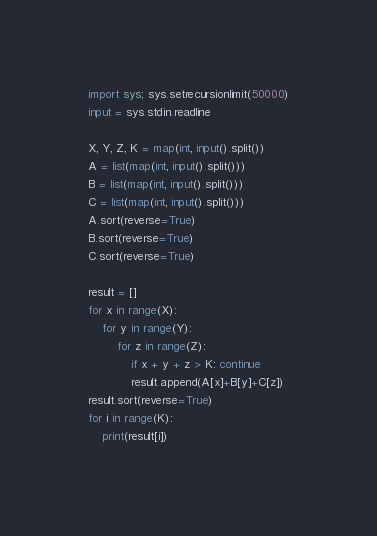Convert code to text. <code><loc_0><loc_0><loc_500><loc_500><_Python_>import sys; sys.setrecursionlimit(50000)
input = sys.stdin.readline

X, Y, Z, K = map(int, input().split())
A = list(map(int, input().split()))
B = list(map(int, input().split()))
C = list(map(int, input().split()))
A.sort(reverse=True)
B.sort(reverse=True)
C.sort(reverse=True)

result = []
for x in range(X):
    for y in range(Y):
        for z in range(Z):
            if x + y + z > K: continue
            result.append(A[x]+B[y]+C[z])
result.sort(reverse=True)
for i in range(K):
    print(result[i])
</code> 